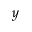<formula> <loc_0><loc_0><loc_500><loc_500>y</formula> 